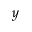<formula> <loc_0><loc_0><loc_500><loc_500>y</formula> 